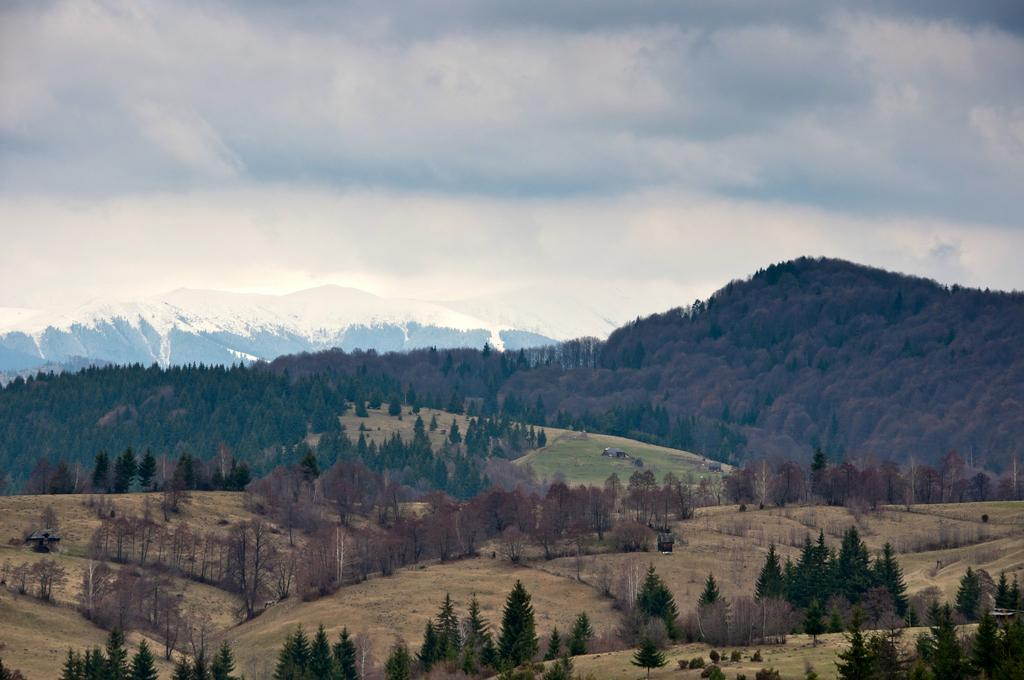What type of natural formation can be seen in the image? There are mountains in the image. What other elements are present in the image besides the mountains? There are plants in the image. What can be seen in the background of the image? The sky is visible in the background of the image. What type of vegetable is being served for breakfast in the image? There is no vegetable or breakfast depicted in the image; it features mountains and plants. 